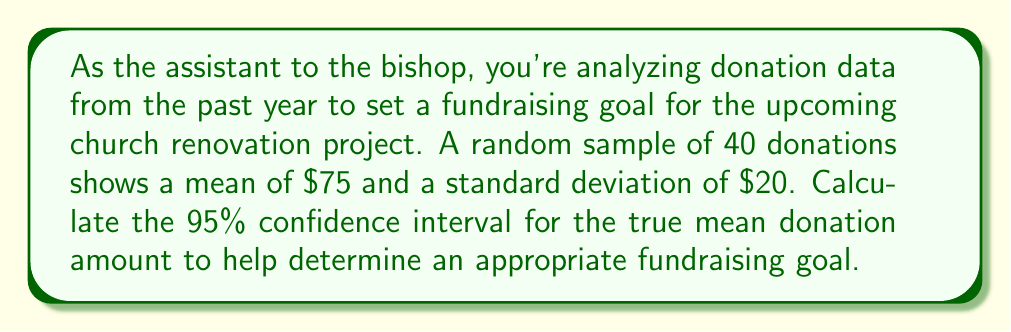Provide a solution to this math problem. To calculate the 95% confidence interval for the true mean donation amount, we'll follow these steps:

1. Identify the known values:
   - Sample size: $n = 40$
   - Sample mean: $\bar{x} = \$75$
   - Sample standard deviation: $s = \$20$
   - Confidence level: 95% (α = 0.05)

2. Find the critical value ($t$-value) for a 95% confidence interval with 39 degrees of freedom:
   $t_{0.025, 39} \approx 2.023$ (from t-distribution table)

3. Calculate the standard error of the mean:
   $SE = \frac{s}{\sqrt{n}} = \frac{20}{\sqrt{40}} = \frac{20}{6.325} \approx 3.162$

4. Compute the margin of error:
   $ME = t_{0.025, 39} \times SE = 2.023 \times 3.162 \approx 6.397$

5. Calculate the confidence interval:
   Lower bound: $\bar{x} - ME = 75 - 6.397 \approx 68.603$
   Upper bound: $\bar{x} + ME = 75 + 6.397 \approx 81.397$

Therefore, the 95% confidence interval for the true mean donation amount is approximately ($68.60, $81.40).

This means we can be 95% confident that the true mean donation amount falls between $68.60 and $81.40. This information can help in setting a realistic fundraising goal for the church renovation project.
Answer: ($68.60, $81.40) 